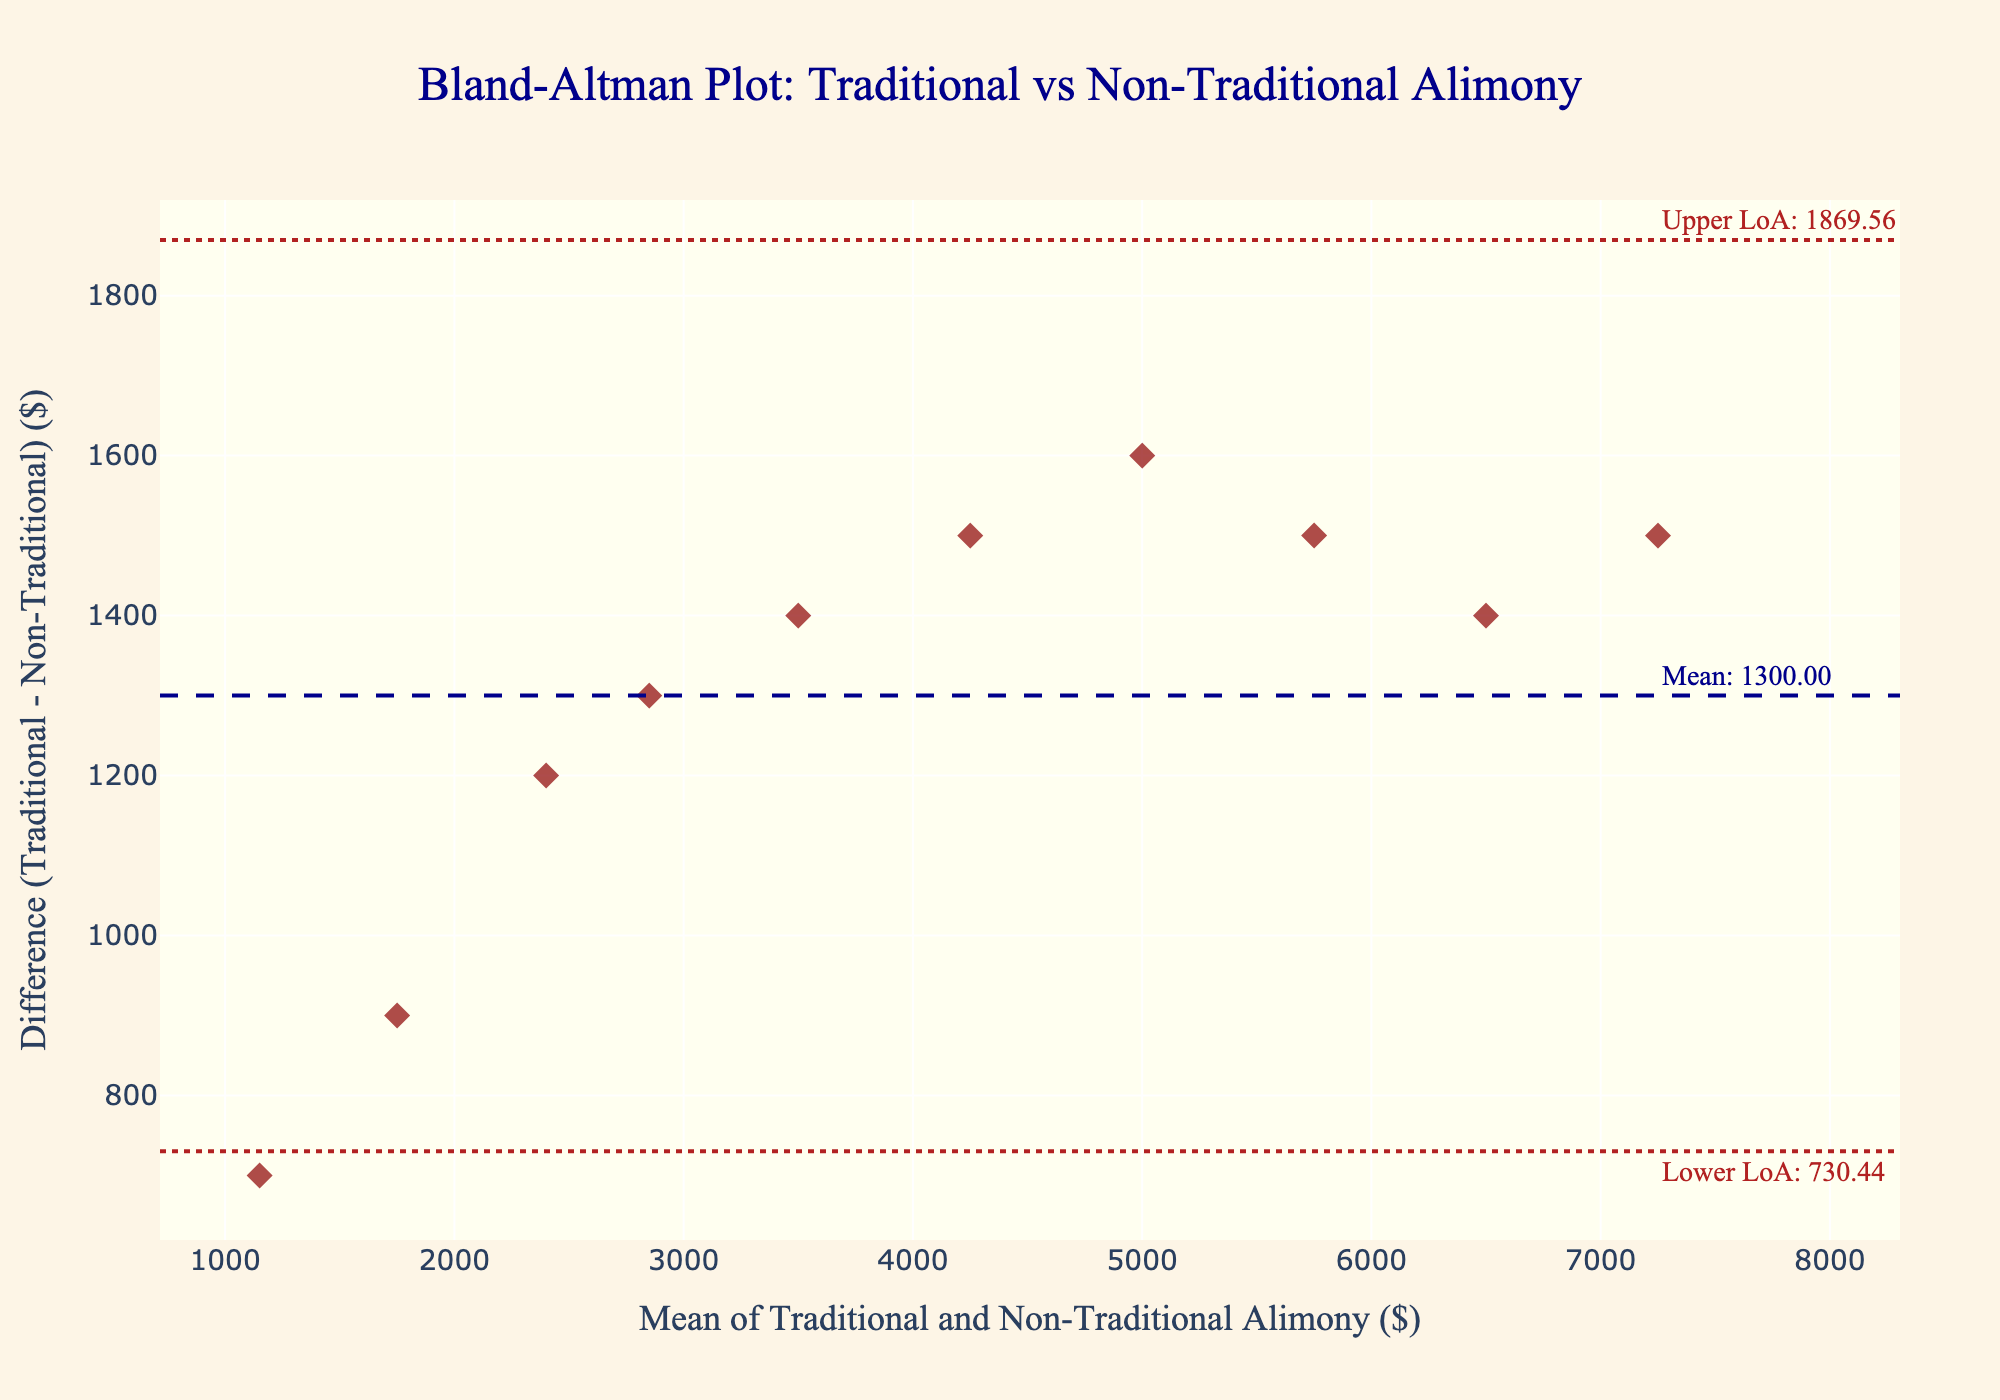How many data points are displayed in the figure? The number of data points corresponds to the number of marriages observed. We can count the marks on the plot to determine this.
Answer: 10 What is the title of the plot? The title is written at the top center of the plot in large, bold text.
Answer: Bland-Altman Plot: Traditional vs Non-Traditional Alimony What does the x-axis represent in the plot? The x-axis title can be found at the bottom of the plot, describing what it measures.
Answer: Mean of Traditional and Non-Traditional Alimony ($) What does the y-axis represent in the plot? The y-axis title is displayed along the left side of the plot, indicating the variable it measures.
Answer: Difference (Traditional - Non-Traditional) ($) What color and shape are the data points? Observing the data points' appearance, we note the color and shape used in the scatter plot.
Answer: Dark red diamonds What is the mean difference value, and where is it located? The mean difference is marked by a horizontal dashed line, with an annotation next to it showing its value.
Answer: Mean: 1800.00 What are the upper and lower limits of agreement, and where are they located? The upper and lower limits of agreement are shown by dotted lines, with annotations indicating their values.
Answer: Upper LoA: 3235.56, Lower LoA: 364.44 What is the range of values on the x-axis? The range is determined by the smallest and largest x-axis tick marks.
Answer: 0 to 8000 Is there a data point that exactly falls on the mean line? Observing the placement of data points in relation to the mean difference line will show whether any point coincides with the line.
Answer: No Compare the spread of data points above and below the mean difference line. Which side has a larger spread? The spread is determined by the vertical distance data points have from the mean difference line.
Answer: Above the mean line Are there any points outside the limits of agreement? Determine whether any data points fall outside the horizontally dotted lines representing the limits of agreement.
Answer: No 